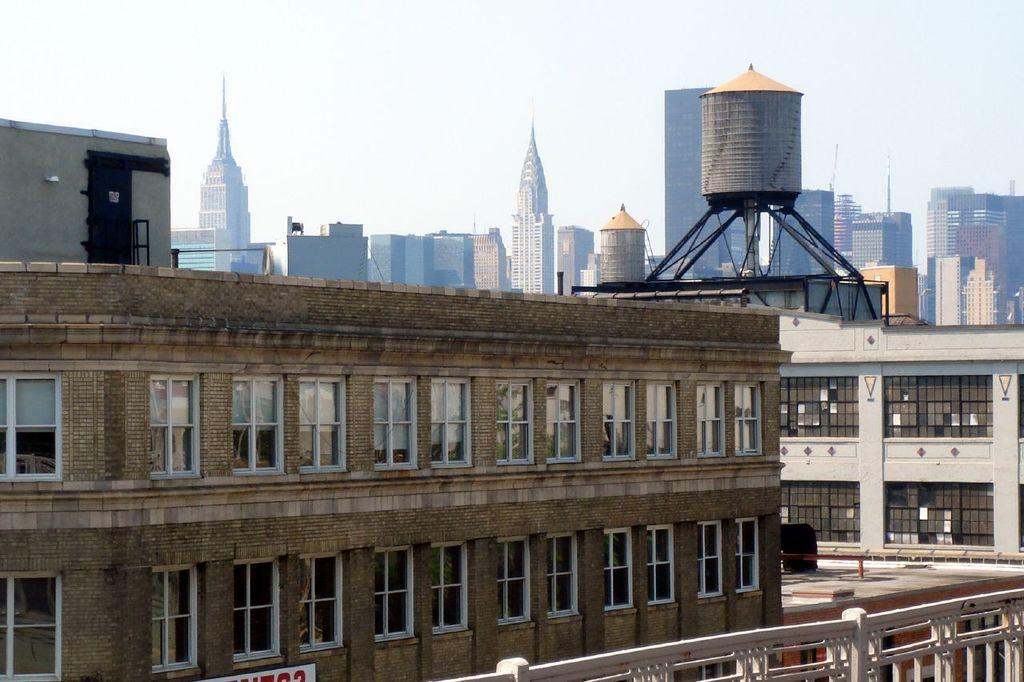What type of structures can be seen in the image? There are buildings in the image. What part of the natural environment is visible in the image? The sky is visible in the background of the image. How many dolls can be seen in the image? There are no dolls present in the image. What is the name of the daughter in the image? There is no mention of a daughter in the image. 